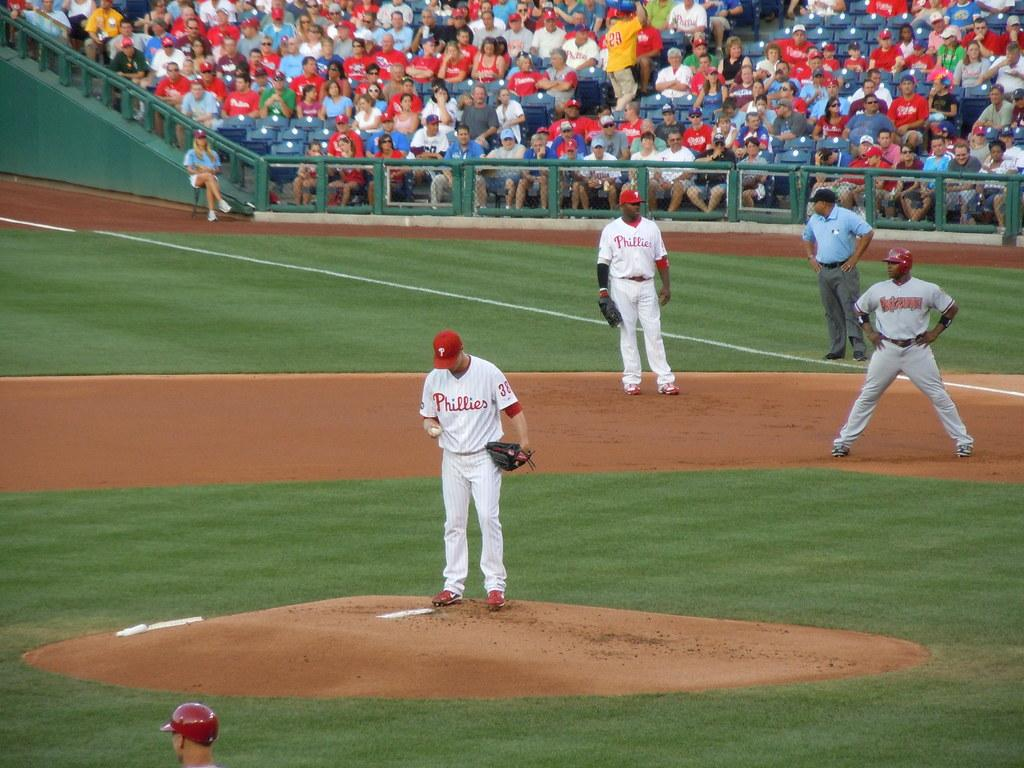<image>
Summarize the visual content of the image. Three players wearing white and all with the word Phillies on the front of their tops stand on the field in front of a large crowd 